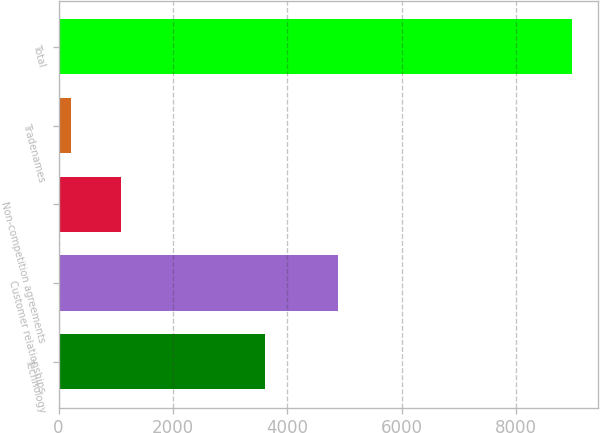Convert chart. <chart><loc_0><loc_0><loc_500><loc_500><bar_chart><fcel>Technology<fcel>Customer relationships<fcel>Non-competition agreements<fcel>Tradenames<fcel>Total<nl><fcel>3611<fcel>4882<fcel>1093.7<fcel>217<fcel>8984<nl></chart> 